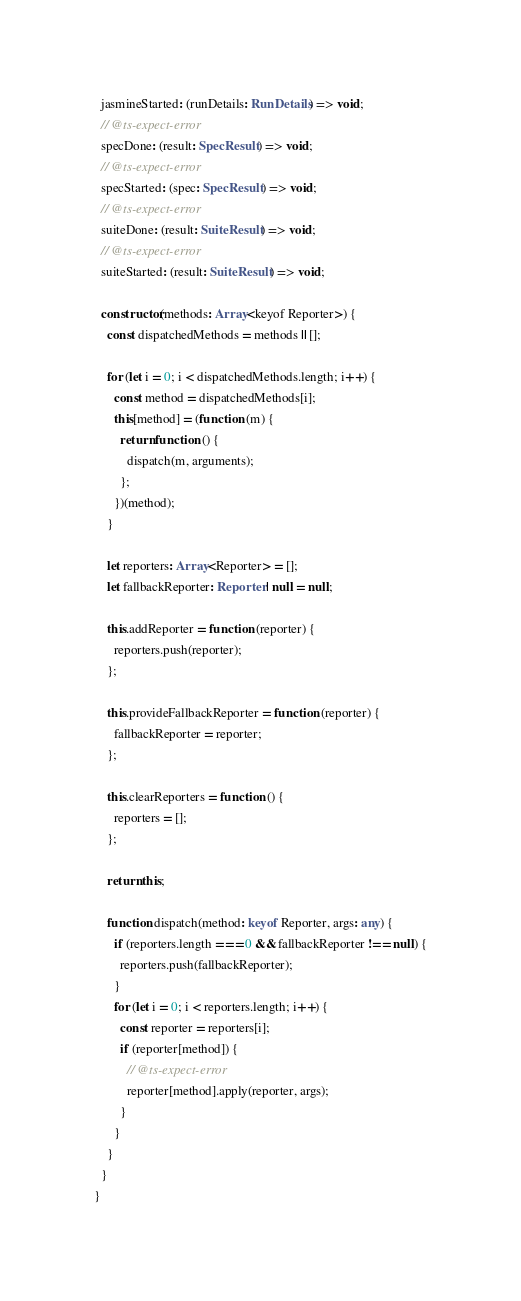Convert code to text. <code><loc_0><loc_0><loc_500><loc_500><_TypeScript_>  jasmineStarted: (runDetails: RunDetails) => void;
  // @ts-expect-error
  specDone: (result: SpecResult) => void;
  // @ts-expect-error
  specStarted: (spec: SpecResult) => void;
  // @ts-expect-error
  suiteDone: (result: SuiteResult) => void;
  // @ts-expect-error
  suiteStarted: (result: SuiteResult) => void;

  constructor(methods: Array<keyof Reporter>) {
    const dispatchedMethods = methods || [];

    for (let i = 0; i < dispatchedMethods.length; i++) {
      const method = dispatchedMethods[i];
      this[method] = (function (m) {
        return function () {
          dispatch(m, arguments);
        };
      })(method);
    }

    let reporters: Array<Reporter> = [];
    let fallbackReporter: Reporter | null = null;

    this.addReporter = function (reporter) {
      reporters.push(reporter);
    };

    this.provideFallbackReporter = function (reporter) {
      fallbackReporter = reporter;
    };

    this.clearReporters = function () {
      reporters = [];
    };

    return this;

    function dispatch(method: keyof Reporter, args: any) {
      if (reporters.length === 0 && fallbackReporter !== null) {
        reporters.push(fallbackReporter);
      }
      for (let i = 0; i < reporters.length; i++) {
        const reporter = reporters[i];
        if (reporter[method]) {
          // @ts-expect-error
          reporter[method].apply(reporter, args);
        }
      }
    }
  }
}
</code> 